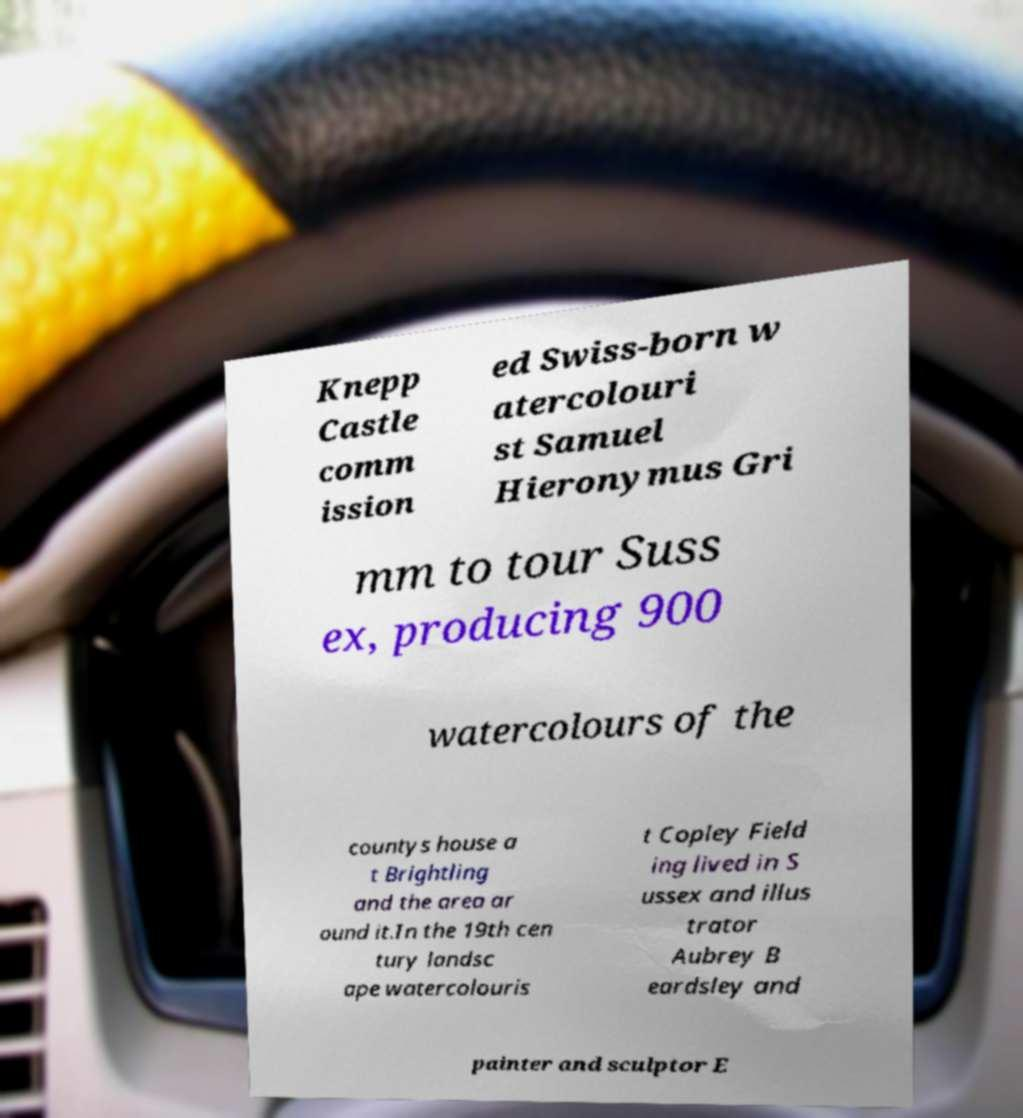Please read and relay the text visible in this image. What does it say? Knepp Castle comm ission ed Swiss-born w atercolouri st Samuel Hieronymus Gri mm to tour Suss ex, producing 900 watercolours of the countys house a t Brightling and the area ar ound it.In the 19th cen tury landsc ape watercolouris t Copley Field ing lived in S ussex and illus trator Aubrey B eardsley and painter and sculptor E 